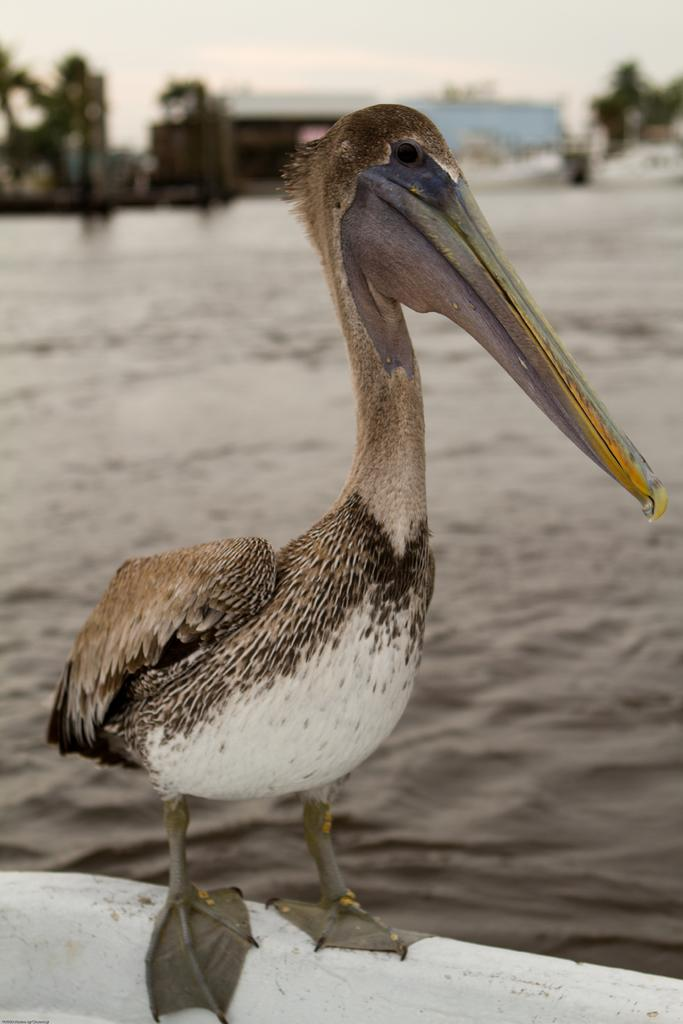What is the main subject of the image? There is a bird standing in the image. What can be seen in the background of the image? Water, the sky, and other objects are visible in the background of the image. What type of business is the bird conducting in the image? There is no indication of a business in the image; it features a bird standing near water and the sky. How many legs does the bird have in the image? The bird has two legs in the image. 